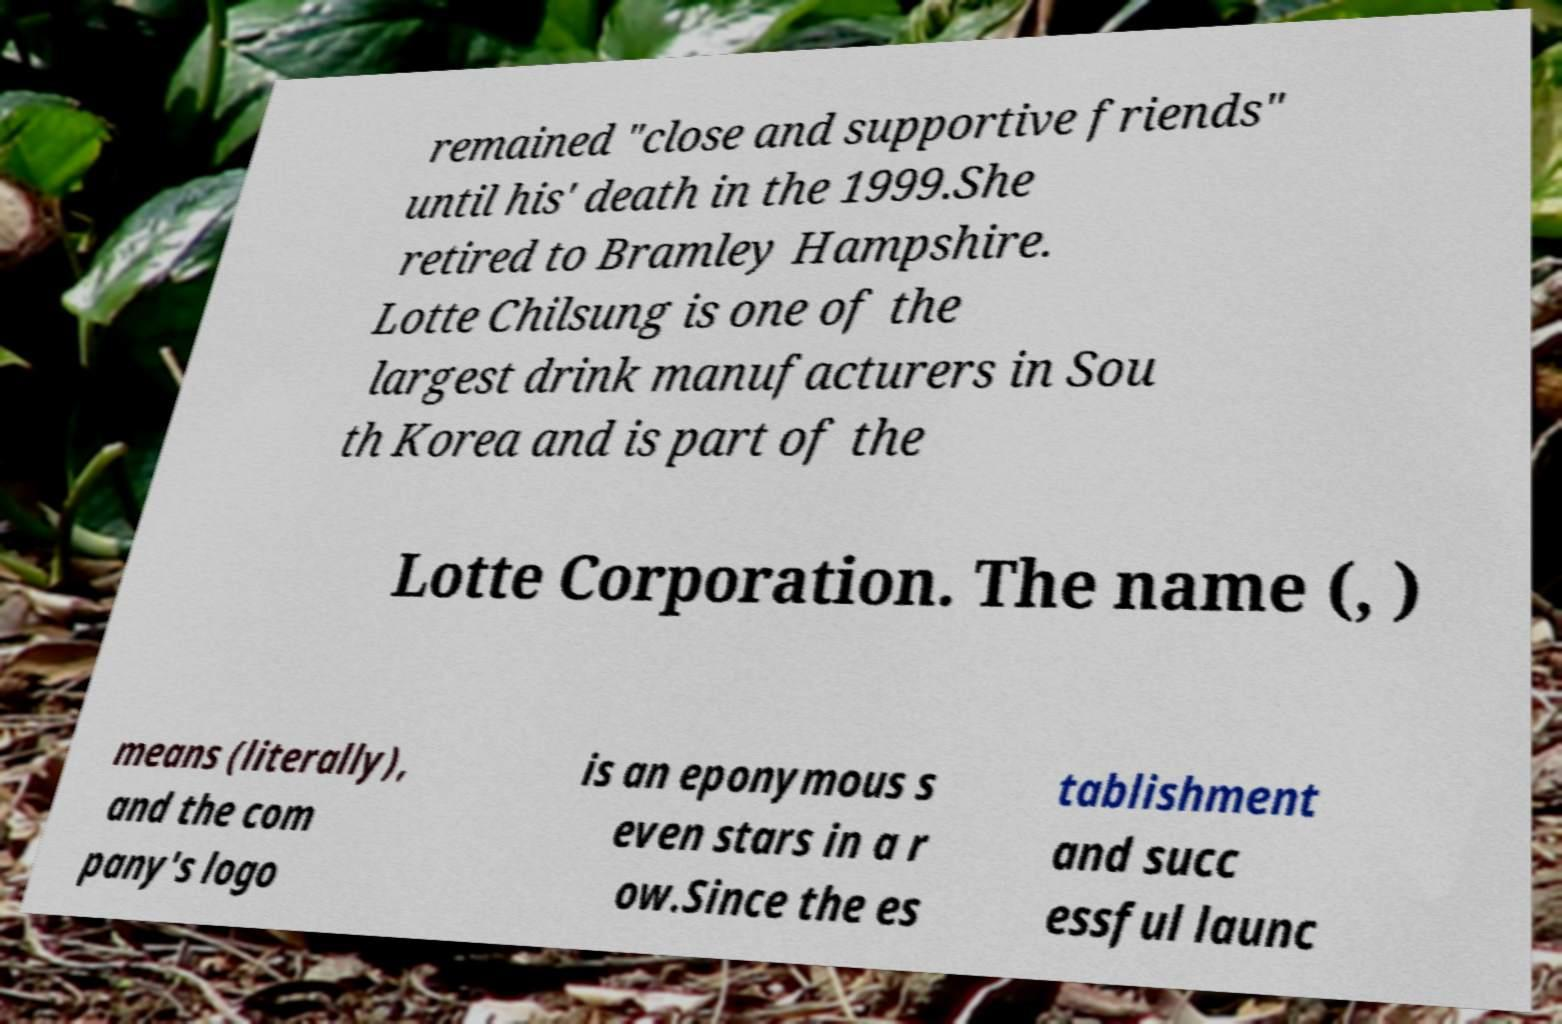There's text embedded in this image that I need extracted. Can you transcribe it verbatim? remained "close and supportive friends" until his' death in the 1999.She retired to Bramley Hampshire. Lotte Chilsung is one of the largest drink manufacturers in Sou th Korea and is part of the Lotte Corporation. The name (, ) means (literally), and the com pany's logo is an eponymous s even stars in a r ow.Since the es tablishment and succ essful launc 